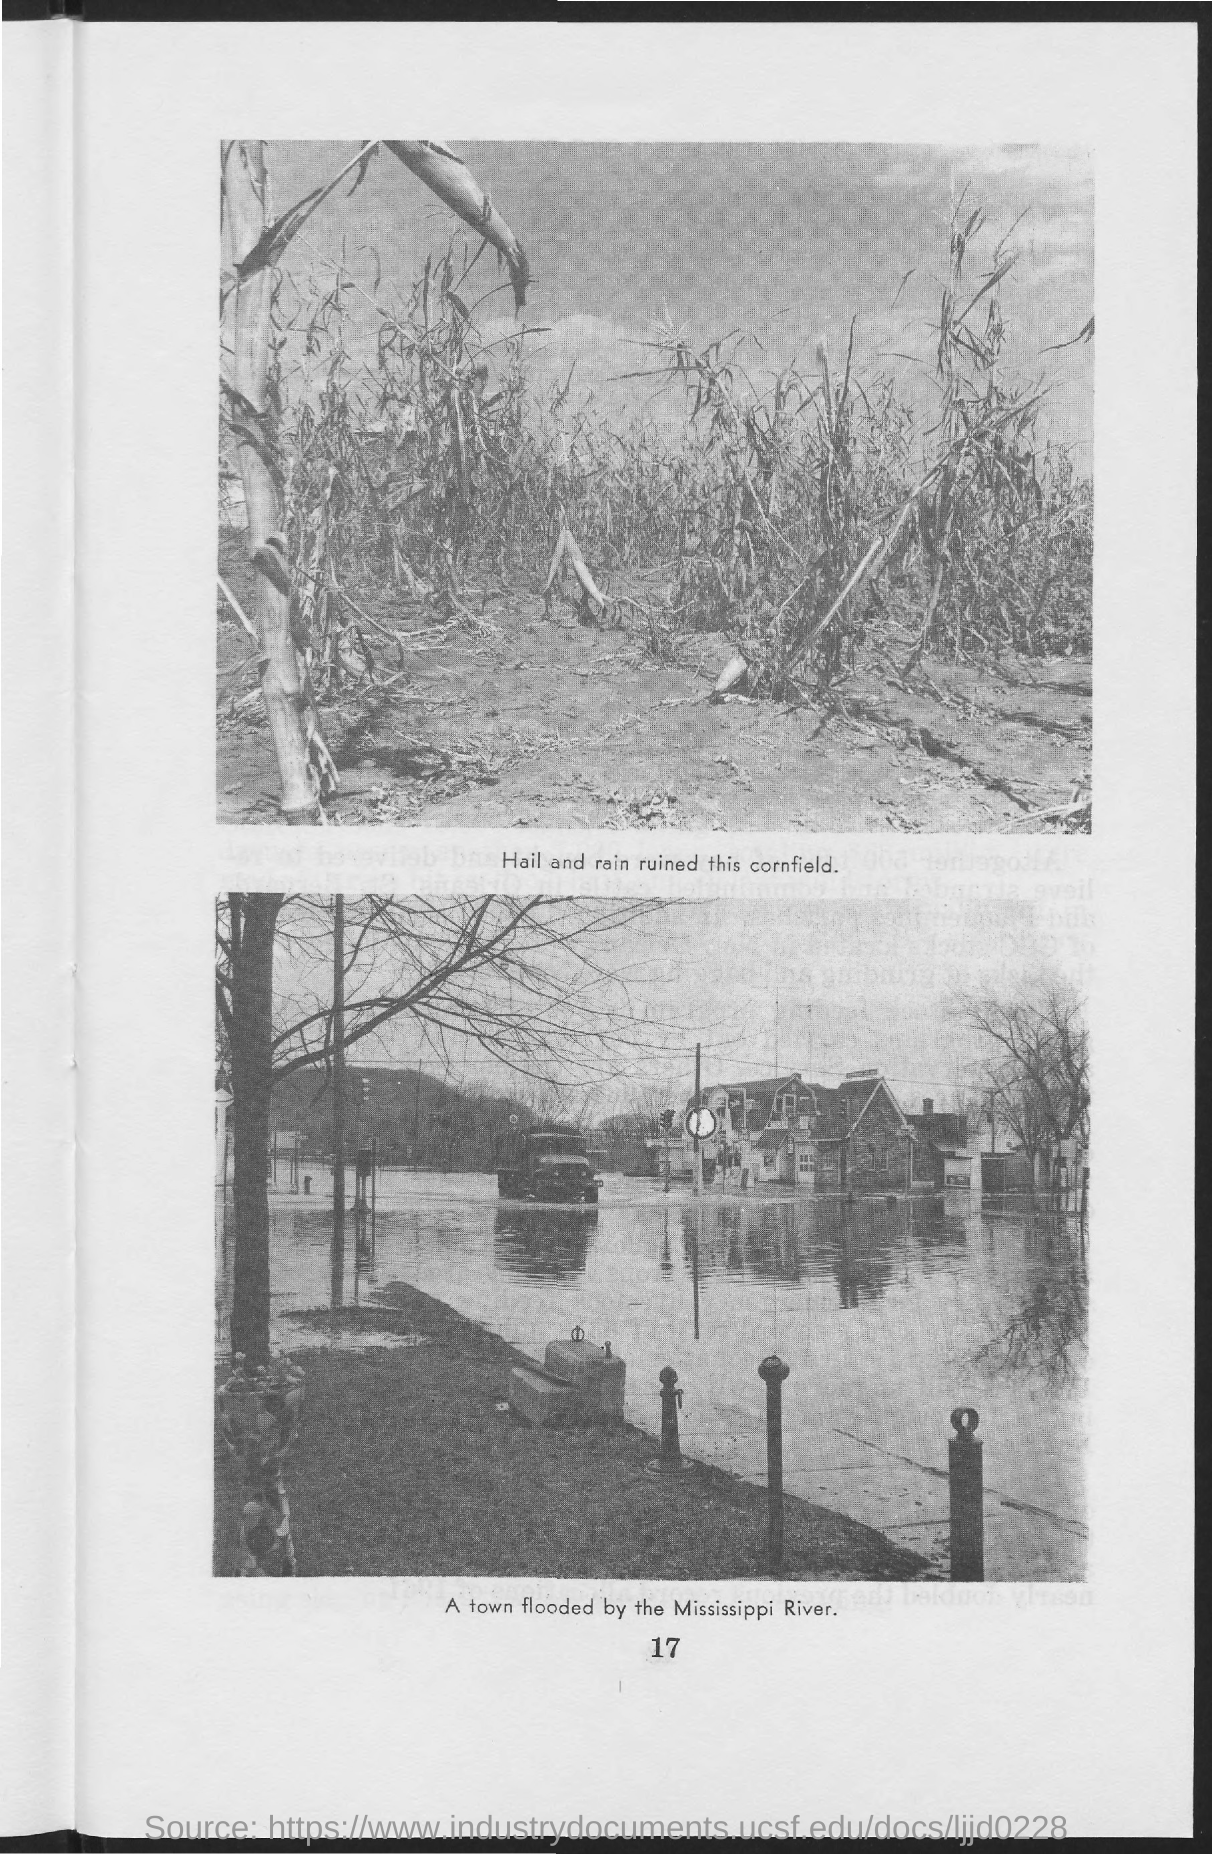What is the page no mentioned in this document?
Make the answer very short. 17. What does the first image in this document signify?
Keep it short and to the point. Hail and rain ruined this cornfield. What does the second image in this document signify?
Ensure brevity in your answer.  A town flooded by the Mississippi River. 